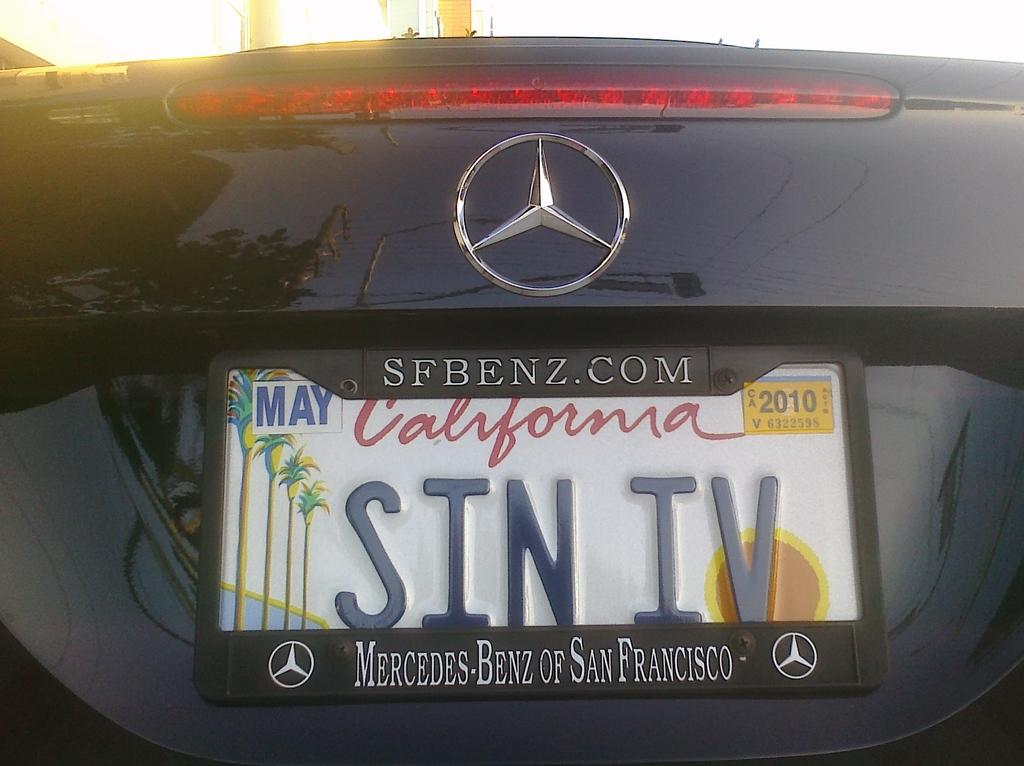<image>
Present a compact description of the photo's key features. A black car has the text SIN IV on the license plate. 